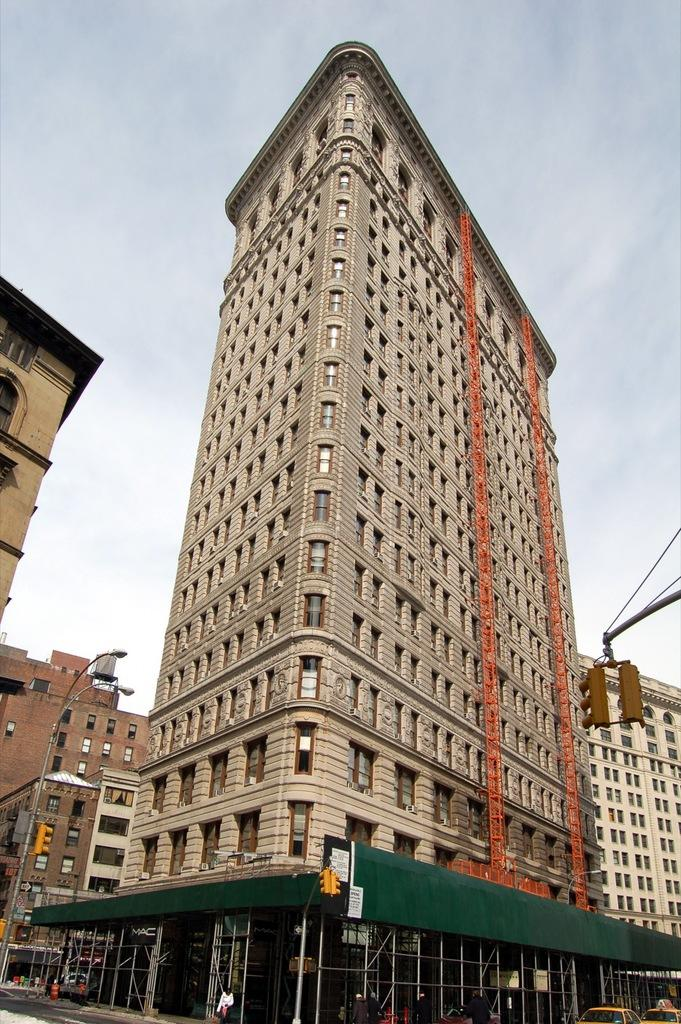What is the main structure in the image? There is a tall tower with plenty of windows in the image. Are there any other structures nearby? Yes, there are other buildings around the tower. What can be seen beside the footpath in the image? There are three traffic signal poles beside the footpath in the image. What word is written on the side of the tall tower in the image? There is no word written on the side of the tall tower in the image. How many toes can be seen on the people walking near the tall tower in the image? There are no people visible in the image, so no toes can be seen. 